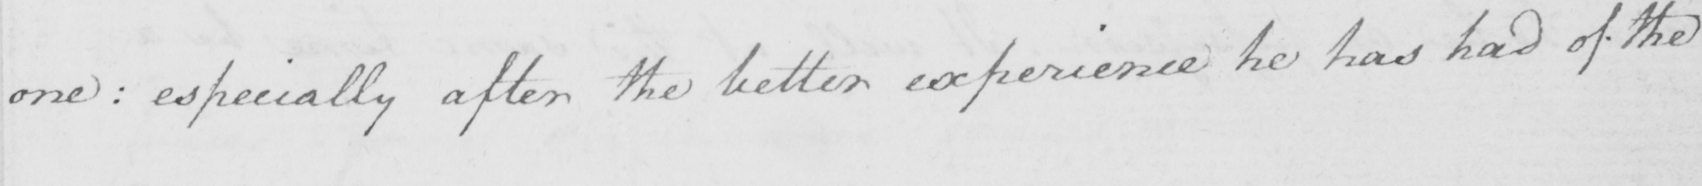What is written in this line of handwriting? one  :  especially after the better experience he has had of the 